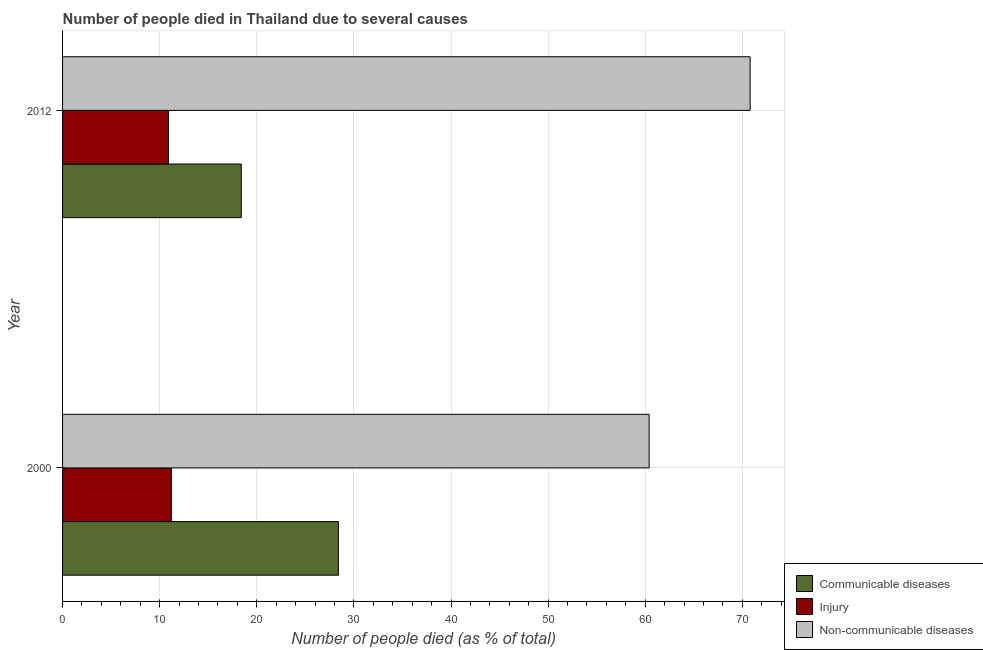Are the number of bars per tick equal to the number of legend labels?
Offer a very short reply. Yes. Are the number of bars on each tick of the Y-axis equal?
Provide a succinct answer. Yes. How many bars are there on the 1st tick from the bottom?
Provide a succinct answer. 3. In how many cases, is the number of bars for a given year not equal to the number of legend labels?
Ensure brevity in your answer.  0. What is the number of people who dies of non-communicable diseases in 2000?
Keep it short and to the point. 60.4. Across all years, what is the minimum number of people who died of communicable diseases?
Offer a very short reply. 18.4. In which year was the number of people who died of injury minimum?
Offer a terse response. 2012. What is the total number of people who dies of non-communicable diseases in the graph?
Offer a very short reply. 131.2. What is the difference between the number of people who died of communicable diseases in 2000 and that in 2012?
Your answer should be compact. 10. What is the difference between the number of people who died of communicable diseases in 2000 and the number of people who dies of non-communicable diseases in 2012?
Keep it short and to the point. -42.4. What is the average number of people who died of communicable diseases per year?
Keep it short and to the point. 23.4. In the year 2012, what is the difference between the number of people who died of communicable diseases and number of people who died of injury?
Your answer should be compact. 7.5. What is the ratio of the number of people who died of injury in 2000 to that in 2012?
Provide a succinct answer. 1.03. Is the number of people who dies of non-communicable diseases in 2000 less than that in 2012?
Your answer should be very brief. Yes. In how many years, is the number of people who died of communicable diseases greater than the average number of people who died of communicable diseases taken over all years?
Make the answer very short. 1. What does the 3rd bar from the top in 2012 represents?
Offer a very short reply. Communicable diseases. What does the 1st bar from the bottom in 2000 represents?
Your answer should be very brief. Communicable diseases. Are all the bars in the graph horizontal?
Give a very brief answer. Yes. Are the values on the major ticks of X-axis written in scientific E-notation?
Provide a succinct answer. No. Does the graph contain any zero values?
Offer a very short reply. No. What is the title of the graph?
Offer a terse response. Number of people died in Thailand due to several causes. Does "Spain" appear as one of the legend labels in the graph?
Your response must be concise. No. What is the label or title of the X-axis?
Ensure brevity in your answer.  Number of people died (as % of total). What is the label or title of the Y-axis?
Your answer should be compact. Year. What is the Number of people died (as % of total) of Communicable diseases in 2000?
Make the answer very short. 28.4. What is the Number of people died (as % of total) of Injury in 2000?
Offer a terse response. 11.2. What is the Number of people died (as % of total) of Non-communicable diseases in 2000?
Make the answer very short. 60.4. What is the Number of people died (as % of total) in Communicable diseases in 2012?
Provide a succinct answer. 18.4. What is the Number of people died (as % of total) in Non-communicable diseases in 2012?
Give a very brief answer. 70.8. Across all years, what is the maximum Number of people died (as % of total) of Communicable diseases?
Offer a very short reply. 28.4. Across all years, what is the maximum Number of people died (as % of total) in Non-communicable diseases?
Make the answer very short. 70.8. Across all years, what is the minimum Number of people died (as % of total) in Communicable diseases?
Offer a very short reply. 18.4. Across all years, what is the minimum Number of people died (as % of total) of Non-communicable diseases?
Make the answer very short. 60.4. What is the total Number of people died (as % of total) of Communicable diseases in the graph?
Ensure brevity in your answer.  46.8. What is the total Number of people died (as % of total) of Injury in the graph?
Ensure brevity in your answer.  22.1. What is the total Number of people died (as % of total) of Non-communicable diseases in the graph?
Your answer should be compact. 131.2. What is the difference between the Number of people died (as % of total) in Injury in 2000 and that in 2012?
Provide a succinct answer. 0.3. What is the difference between the Number of people died (as % of total) in Non-communicable diseases in 2000 and that in 2012?
Make the answer very short. -10.4. What is the difference between the Number of people died (as % of total) of Communicable diseases in 2000 and the Number of people died (as % of total) of Injury in 2012?
Make the answer very short. 17.5. What is the difference between the Number of people died (as % of total) in Communicable diseases in 2000 and the Number of people died (as % of total) in Non-communicable diseases in 2012?
Your response must be concise. -42.4. What is the difference between the Number of people died (as % of total) in Injury in 2000 and the Number of people died (as % of total) in Non-communicable diseases in 2012?
Make the answer very short. -59.6. What is the average Number of people died (as % of total) in Communicable diseases per year?
Make the answer very short. 23.4. What is the average Number of people died (as % of total) of Injury per year?
Provide a succinct answer. 11.05. What is the average Number of people died (as % of total) in Non-communicable diseases per year?
Your answer should be compact. 65.6. In the year 2000, what is the difference between the Number of people died (as % of total) of Communicable diseases and Number of people died (as % of total) of Injury?
Offer a terse response. 17.2. In the year 2000, what is the difference between the Number of people died (as % of total) of Communicable diseases and Number of people died (as % of total) of Non-communicable diseases?
Your answer should be very brief. -32. In the year 2000, what is the difference between the Number of people died (as % of total) in Injury and Number of people died (as % of total) in Non-communicable diseases?
Provide a short and direct response. -49.2. In the year 2012, what is the difference between the Number of people died (as % of total) in Communicable diseases and Number of people died (as % of total) in Non-communicable diseases?
Ensure brevity in your answer.  -52.4. In the year 2012, what is the difference between the Number of people died (as % of total) in Injury and Number of people died (as % of total) in Non-communicable diseases?
Ensure brevity in your answer.  -59.9. What is the ratio of the Number of people died (as % of total) in Communicable diseases in 2000 to that in 2012?
Provide a succinct answer. 1.54. What is the ratio of the Number of people died (as % of total) in Injury in 2000 to that in 2012?
Provide a succinct answer. 1.03. What is the ratio of the Number of people died (as % of total) of Non-communicable diseases in 2000 to that in 2012?
Your response must be concise. 0.85. What is the difference between the highest and the second highest Number of people died (as % of total) in Non-communicable diseases?
Your answer should be compact. 10.4. What is the difference between the highest and the lowest Number of people died (as % of total) of Injury?
Keep it short and to the point. 0.3. What is the difference between the highest and the lowest Number of people died (as % of total) in Non-communicable diseases?
Ensure brevity in your answer.  10.4. 